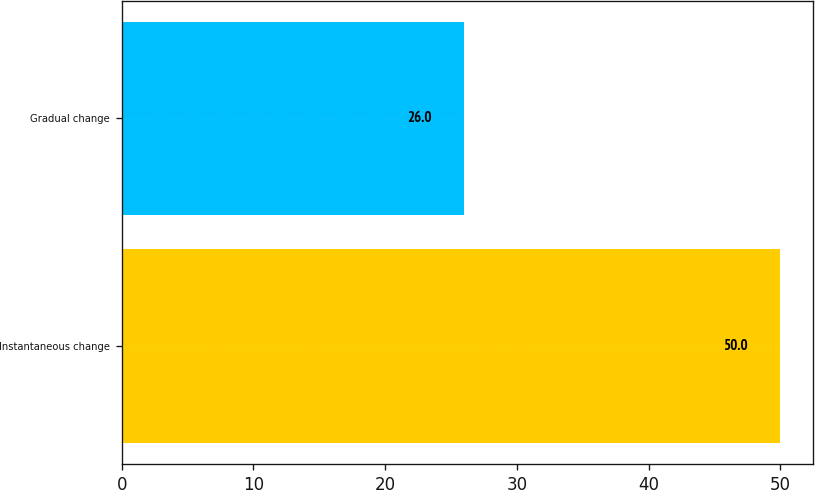<chart> <loc_0><loc_0><loc_500><loc_500><bar_chart><fcel>Instantaneous change<fcel>Gradual change<nl><fcel>50<fcel>26<nl></chart> 